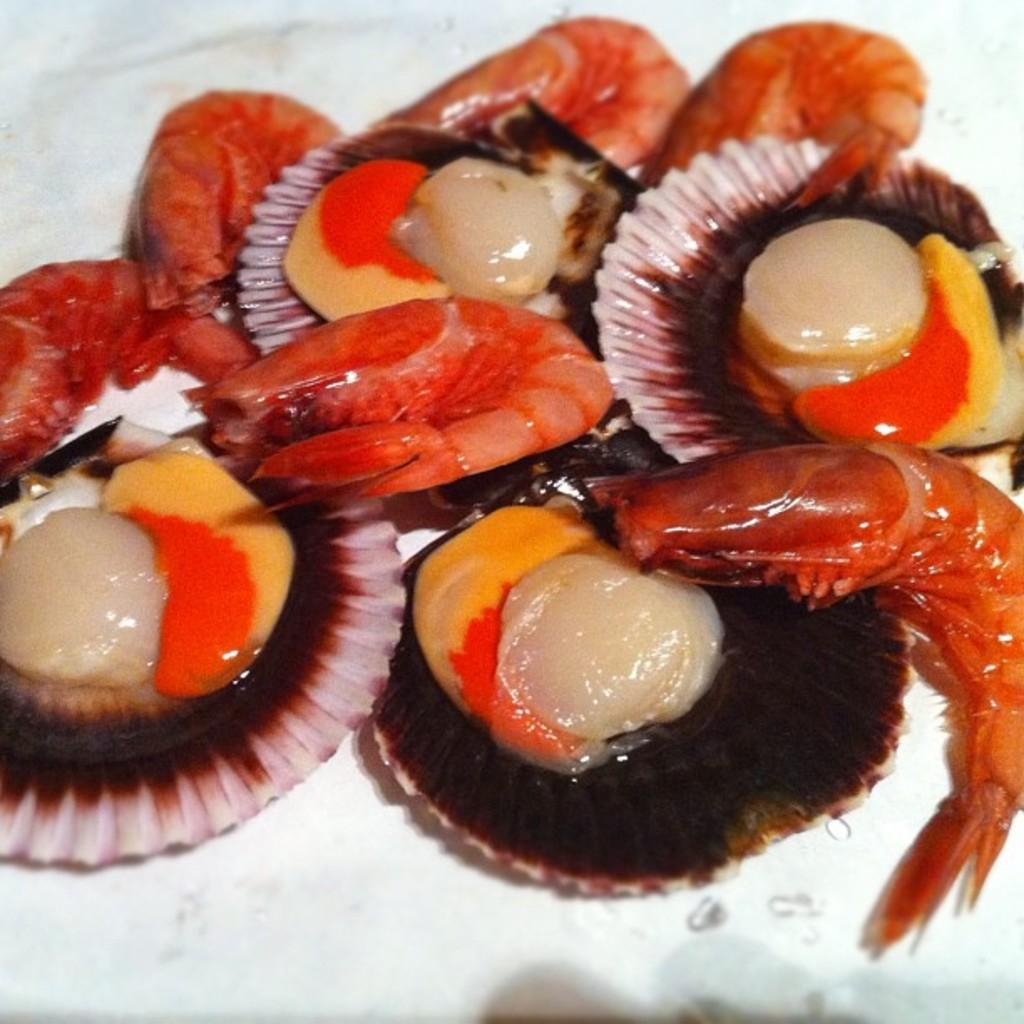What type of seafood is present in the image? There are prawns in the image. What other items related to the sea can be seen in the image? There are sea shells in the image. How are the prawns and sea shells arranged in the image? The prawns and sea shells are arranged in a circular pattern. What type of rice is being cracked in the image? There is no rice or cracking activity present in the image. 